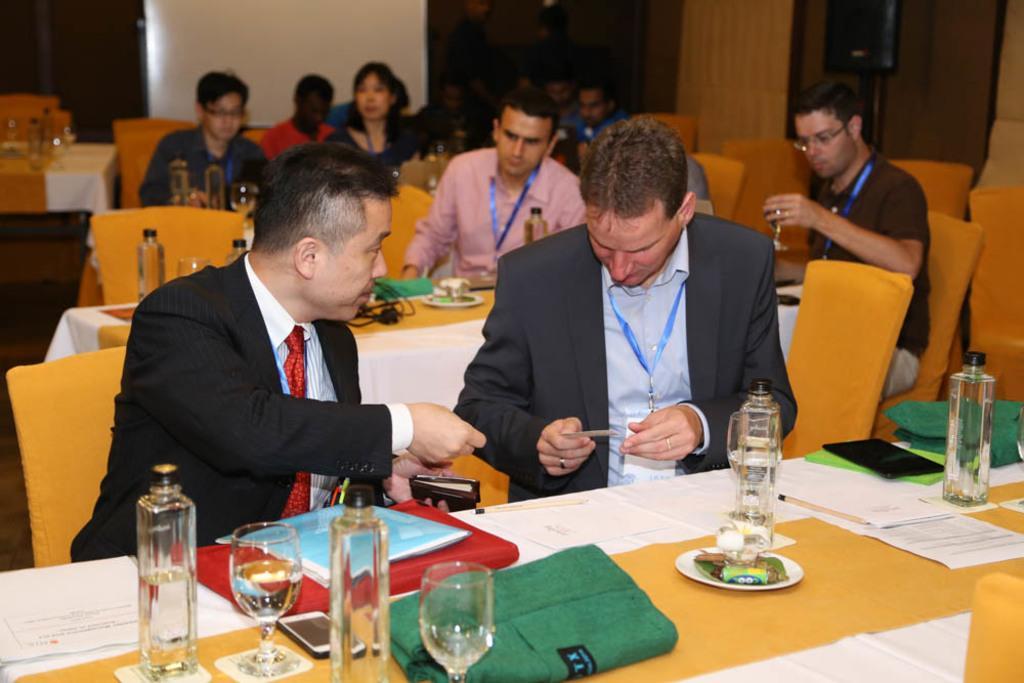Describe this image in one or two sentences. In this picture, we can see a few people sitting, and we can see tables, and some objects on tables like plates, jars, glasses, and we can see chairs, and the wall. 